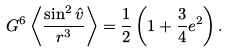Convert formula to latex. <formula><loc_0><loc_0><loc_500><loc_500>G ^ { 6 } \left < \frac { \sin ^ { 2 } { \hat { v } } } { r ^ { 3 } } \right > = \frac { 1 } { 2 } \left ( 1 + \frac { 3 } { 4 } e ^ { 2 } \right ) .</formula> 